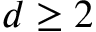<formula> <loc_0><loc_0><loc_500><loc_500>d \geq 2</formula> 